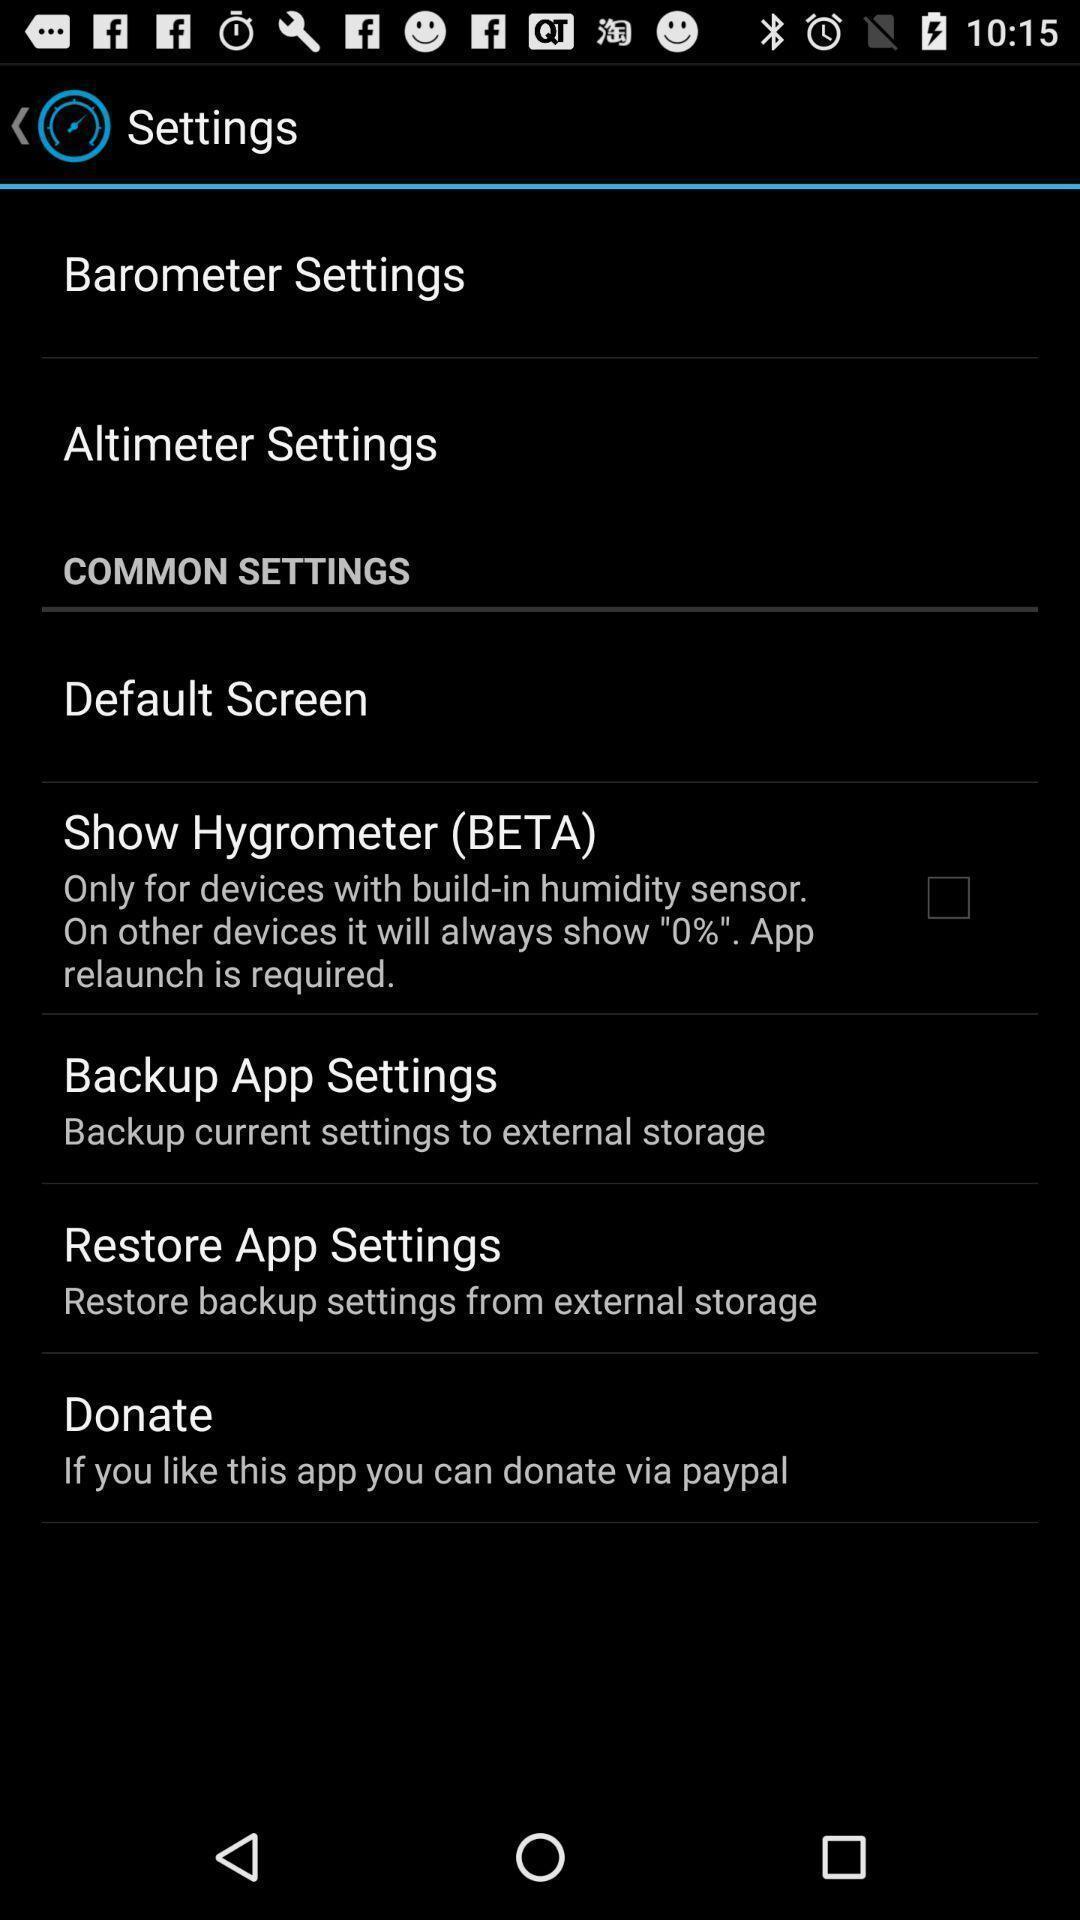Explain the elements present in this screenshot. Page is about settings of barometer. 